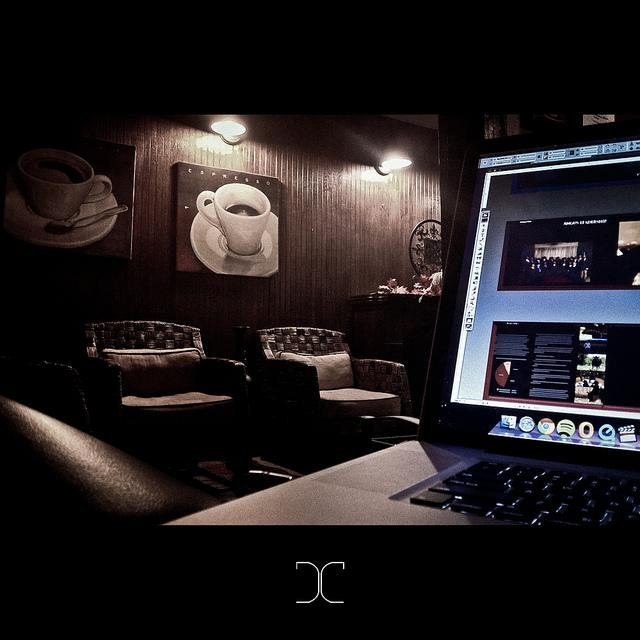What company is the main competitor to the laptop's operating system? Please explain your reasoning. microsoft. The laptop is a macbook. 